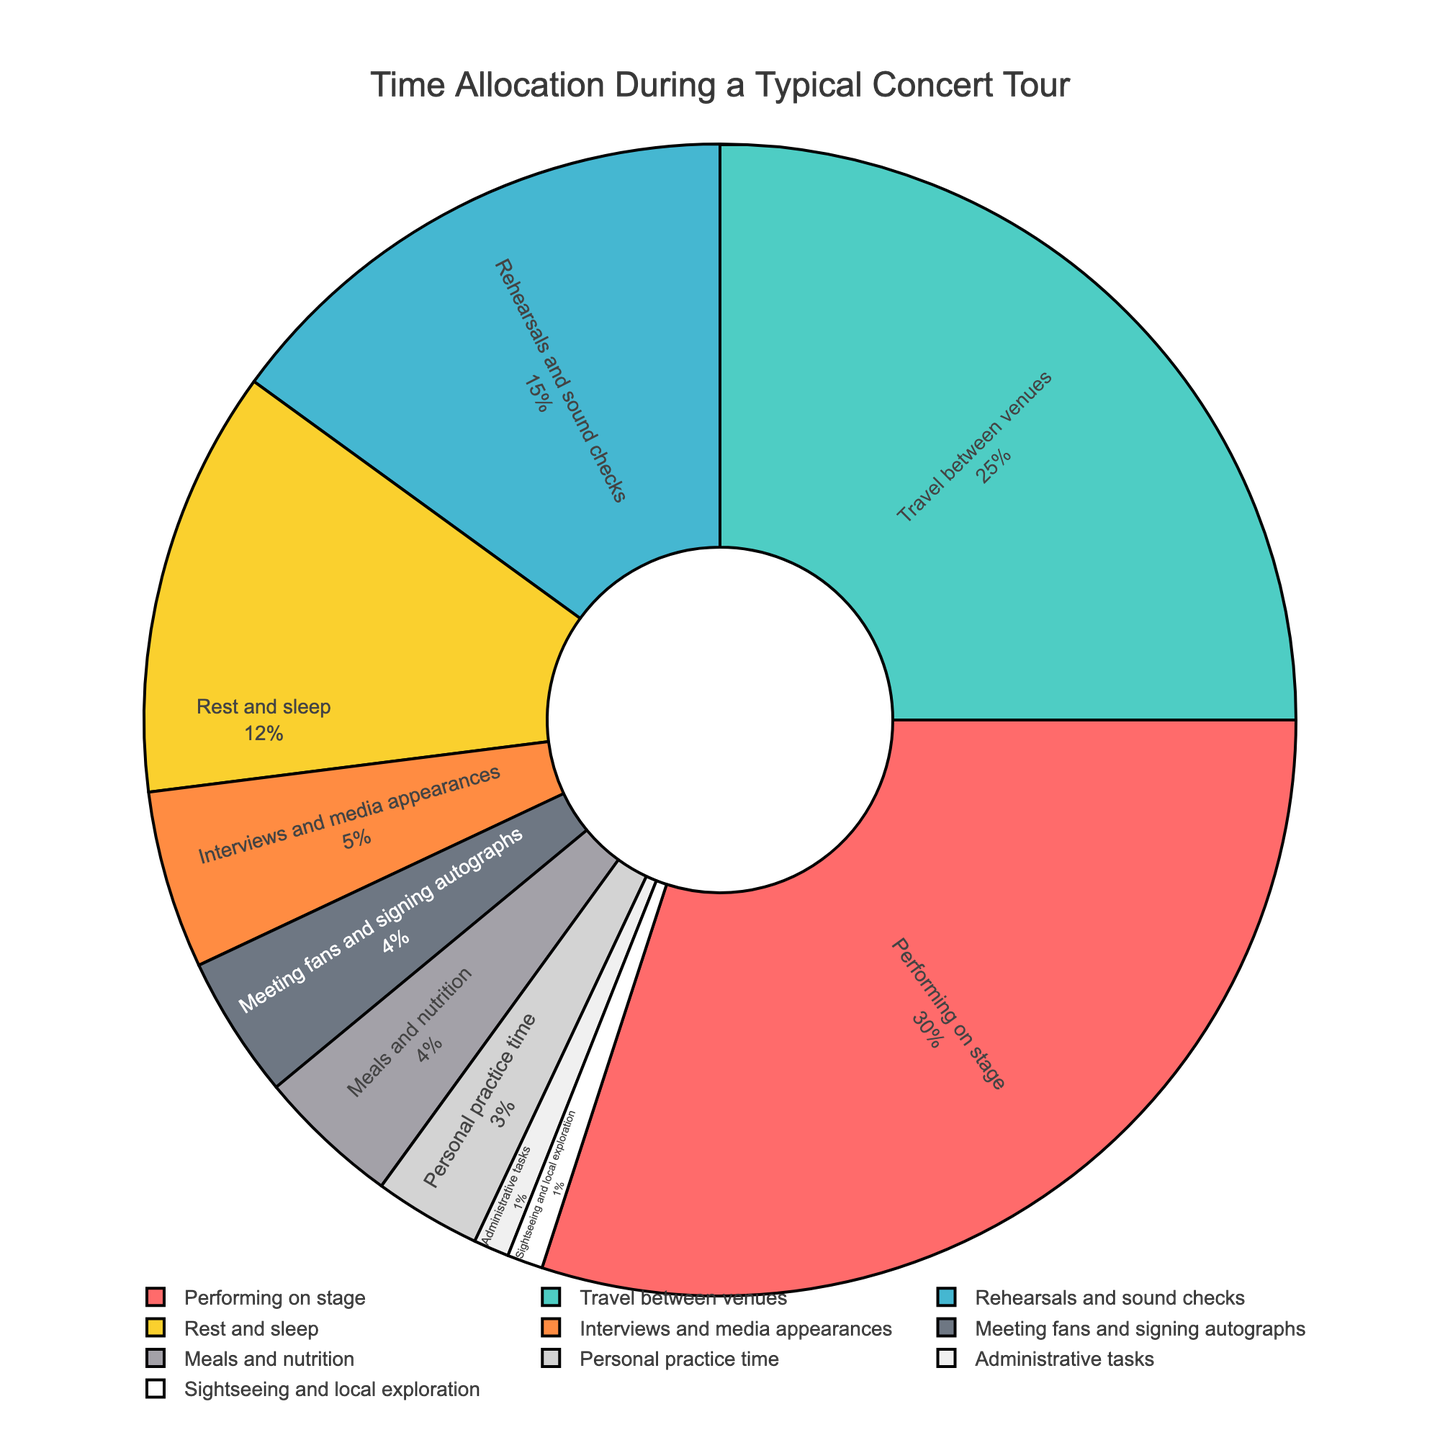How much time is spent on rehearsals and sound checks compared to performing on stage? The percentage of time spent on rehearsals and sound checks is 15%, whereas for performing on stage it is 30%. To compare: 30% (performing) - 15% (rehearsals) = 15%.
Answer: 15% Which activity takes up the least time during a typical concert tour? By looking at the figure, we see that both administrative tasks and sightseeing and local exploration are at 1%.
Answer: Administrative tasks and sightseeing What proportion of the total time is spent on both travel between venues and rest and sleep combined? The percentage of time spent on travel between venues is 25%, and on rest and sleep it's 12%. To find the combined proportion: 25% + 12% = 37%.
Answer: 37% Is more time spent on interviews and media appearances or on meals and nutrition? According to the figure, 5% of the time is spent on interviews and media appearances, while 4% is spent on meals and nutrition. Therefore, interviews and media appearances take up more time.
Answer: Interviews and media appearances What is the sum of time allocated to administrative tasks, sightseeing and local exploration, and meeting fans and signing autographs? The percentage of time spent on administrative tasks is 1%, sightseeing and local exploration is 1%, and meeting fans and signing autographs is 4%. To get the total: 1% + 1% + 4% = 6%.
Answer: 6% Which activity sector is color-coded in red in the chart? The red color-coded sector in the pie chart represents performing on stage. This is determined by referring to the color scheme and the corresponding activity.
Answer: Performing on stage What is the difference in time allocation between personal practice time and meals and nutrition? Personal practice time is 3%, while meals and nutrition is 4%. The difference between the two is: 4% - 3% = 1%.
Answer: 1% How much more time is spent on rehearsals and sound checks compared to interviews and media appearances? Rehearsals and sound checks account for 15% of the time, whereas interviews and media appearances account for 5%. The difference is: 15% - 5% = 10%.
Answer: 10% What fraction of the total time is spent on personal practice time? The time allocated to personal practice time is 3%. To find the fraction: 3% of 100% = 3/100.
Answer: 3/100 Are there more activities that take up 4% or less time or more than 4%? There are six activities (rest and sleep, interviews and media appearances, meeting fans and signing autographs, meals and nutrition, personal practice time, administrative tasks, and sightseeing) that occupy 4% or less time. There are four activities (performing on stage, travel between venues, rehearsals and sound checks) that occupy more than 4% time. Therefore, more activities take up 4% or less.
Answer: 4% or less 